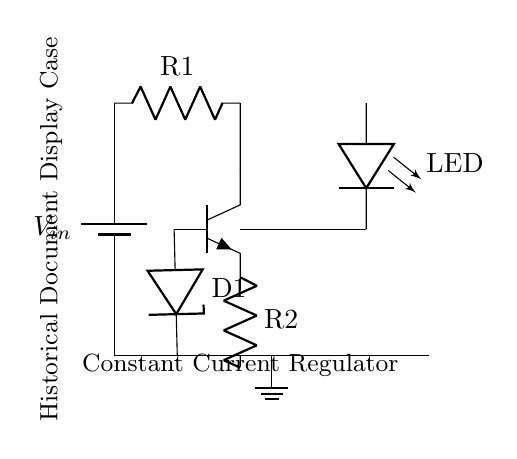What is the power supply component used in the circuit? The power supply component is a battery, as indicated by the symbol near the top left of the circuit diagram.
Answer: battery Which component is responsible for regulating the current to the LED? The transistor (npn) is responsible for regulating the current to the LED by controlling the flow of electricity based on the voltage at its base.
Answer: transistor What is the purpose of the Zener diode in this circuit? The Zener diode is used to maintain a constant voltage level at the base of the transistor, ensuring stable operation and preventing fluctuations in current supply to the LED.
Answer: voltage stabilization How many resistors are present in the circuit? There are two resistors in the circuit, denoted as R1 and R2.
Answer: two What may happen if R2’s value is decreased? If R2’s value is decreased, the current flowing through the LED may increase, potentially leading to the LED burning out due to excessive current.
Answer: LED burn out What is the symbol used for the LED in this circuit diagram? The LED is represented by the symbol "leDo" in the circuit diagram.
Answer: leDo What does the label 'Constant Current Regulator' indicate in the circuit? The label indicates that the circuit is designed to maintain a steady current flowing through the connected components, particularly the LED, regardless of variations in supply voltage.
Answer: constant current regulation 